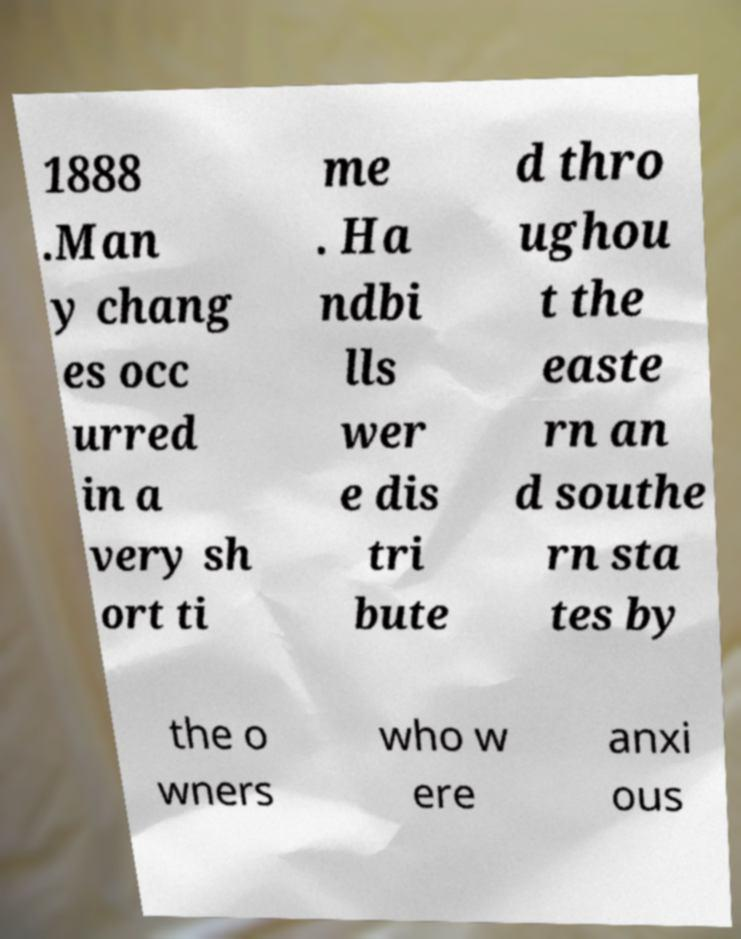There's text embedded in this image that I need extracted. Can you transcribe it verbatim? 1888 .Man y chang es occ urred in a very sh ort ti me . Ha ndbi lls wer e dis tri bute d thro ughou t the easte rn an d southe rn sta tes by the o wners who w ere anxi ous 